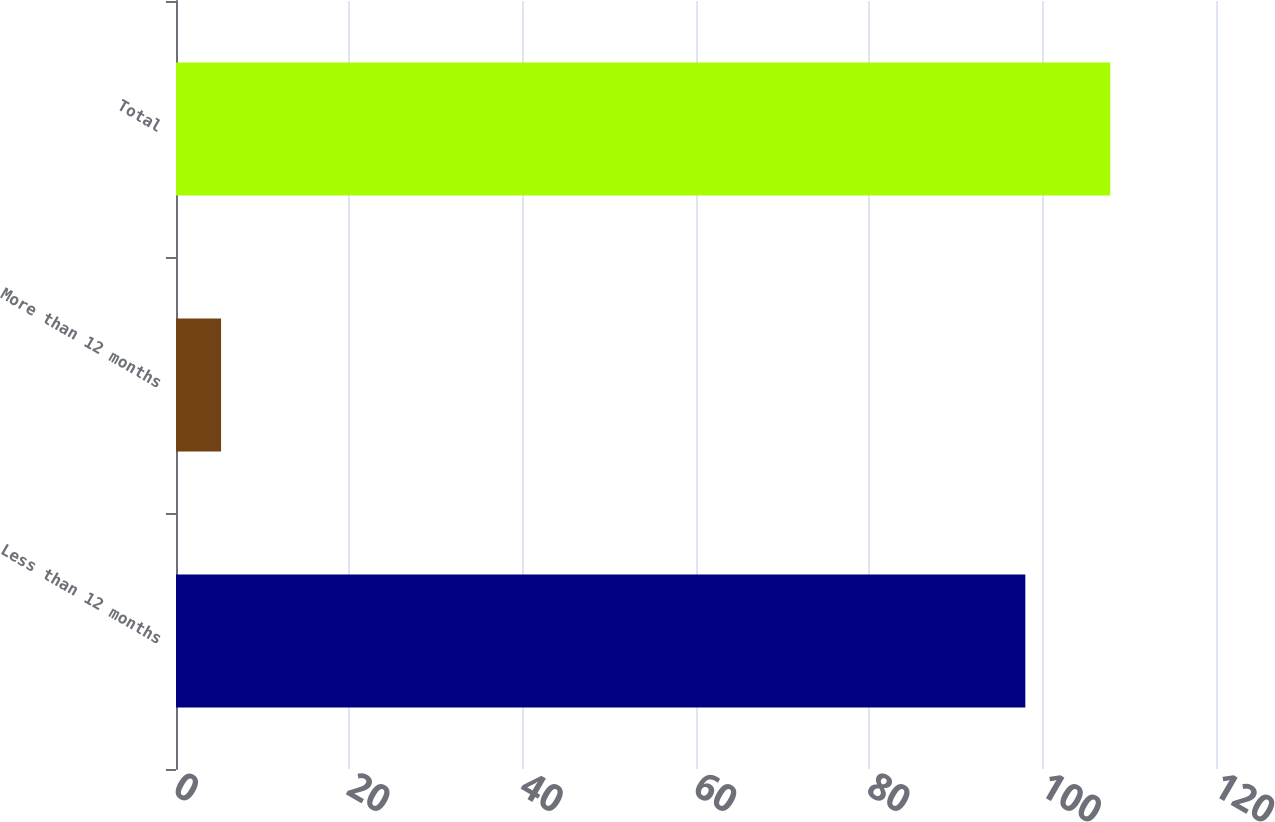Convert chart. <chart><loc_0><loc_0><loc_500><loc_500><bar_chart><fcel>Less than 12 months<fcel>More than 12 months<fcel>Total<nl><fcel>98<fcel>5.2<fcel>107.8<nl></chart> 